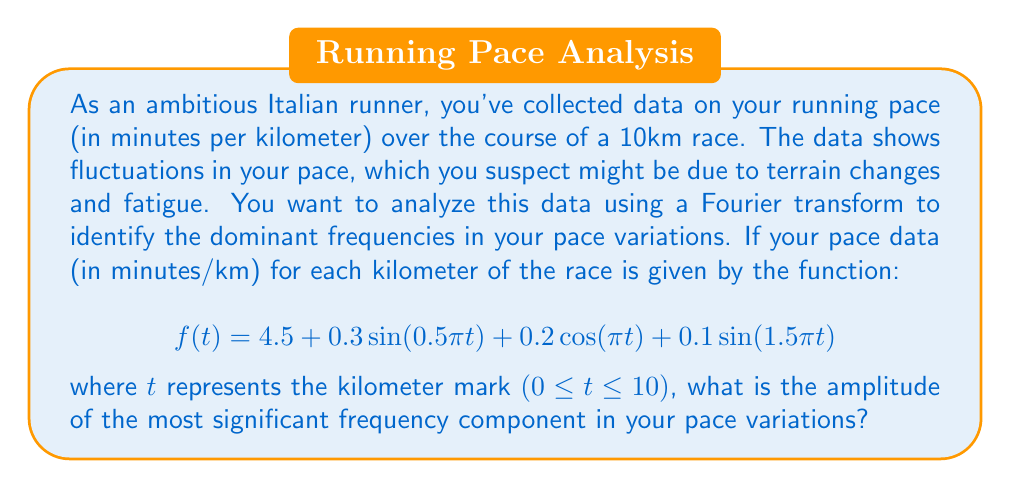Teach me how to tackle this problem. To solve this problem, we need to analyze the given function using Fourier transform principles. Let's break it down step by step:

1) The given function represents your pace over the course of the race:

   $$f(t) = 4.5 + 0.3\sin(0.5\pi t) + 0.2\cos(\pi t) + 0.1\sin(1.5\pi t)$$

2) In this function, 4.5 represents your average pace (in minutes/km), and the other terms represent variations in your pace.

3) To find the most significant frequency component, we need to compare the amplitudes of the sinusoidal terms:

   - $0.3\sin(0.5\pi t)$ has an amplitude of 0.3
   - $0.2\cos(\pi t)$ has an amplitude of 0.2
   - $0.1\sin(1.5\pi t)$ has an amplitude of 0.1

4) The Fourier transform would decompose this function into its frequency components. In this case, we can directly observe the frequency components from the given function.

5) The term with the largest amplitude represents the most significant frequency component in your pace variations.

6) Comparing the amplitudes:
   0.3 > 0.2 > 0.1

Therefore, the term $0.3\sin(0.5\pi t)$ represents the most significant frequency component in your pace variations.
Answer: The amplitude of the most significant frequency component in your pace variations is 0.3 minutes/km. 